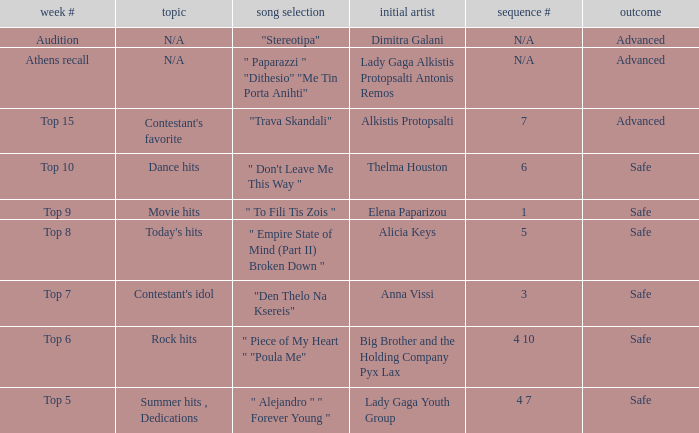Which artists have order number 6? Thelma Houston. 